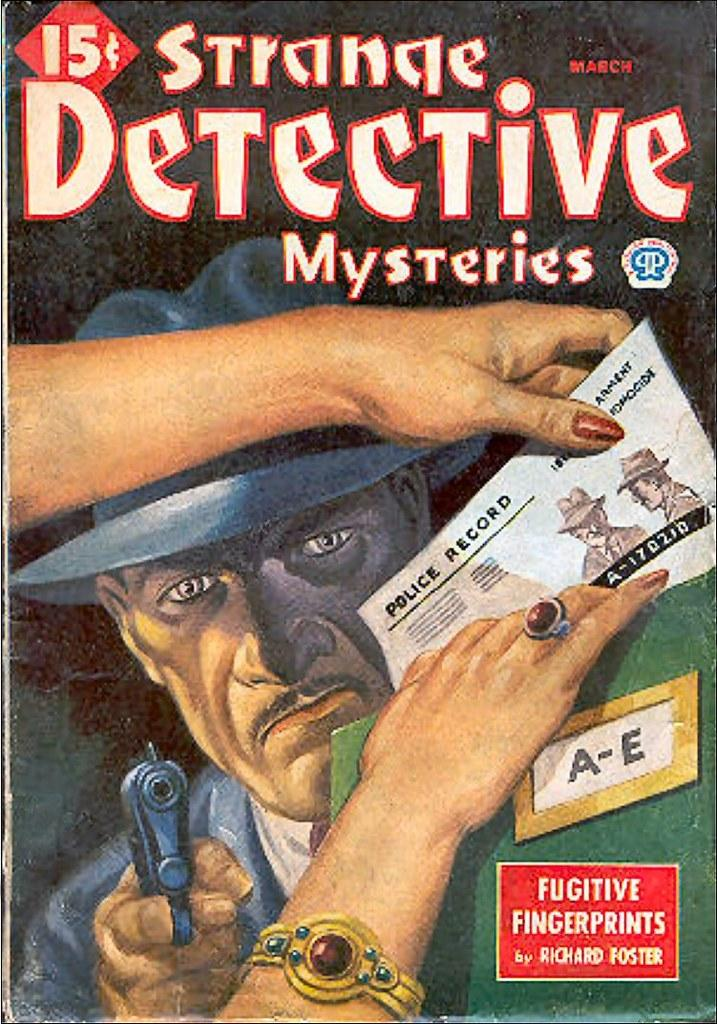<image>
Describe the image concisely. The Strange Detective Mysteries are written by Richard Foster. 